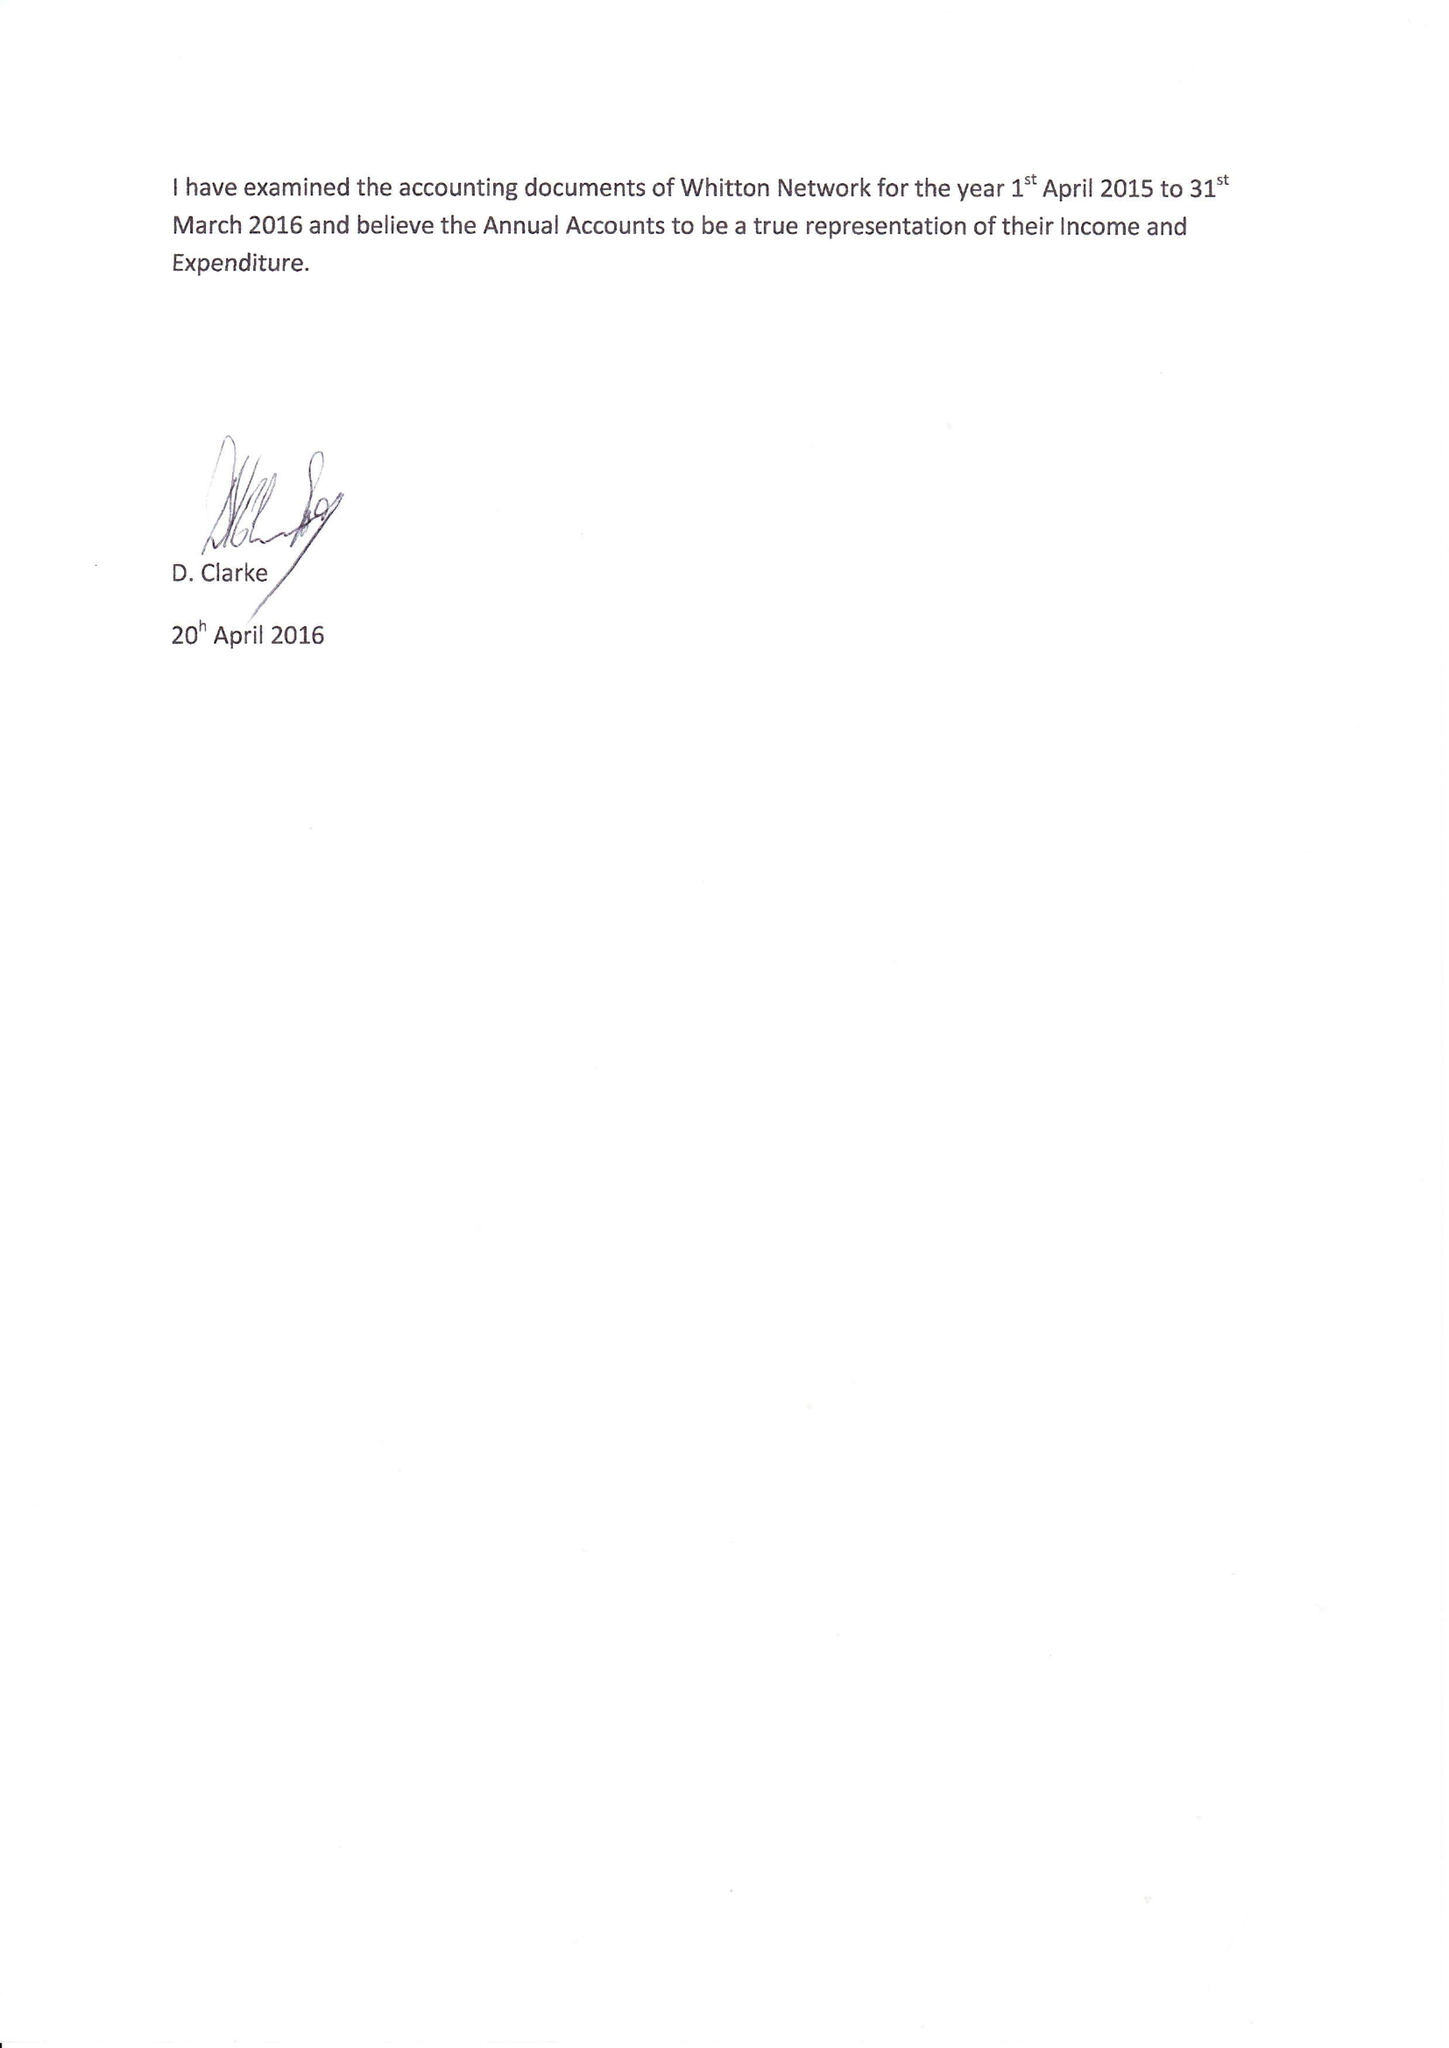What is the value for the charity_number?
Answer the question using a single word or phrase. 1117627 